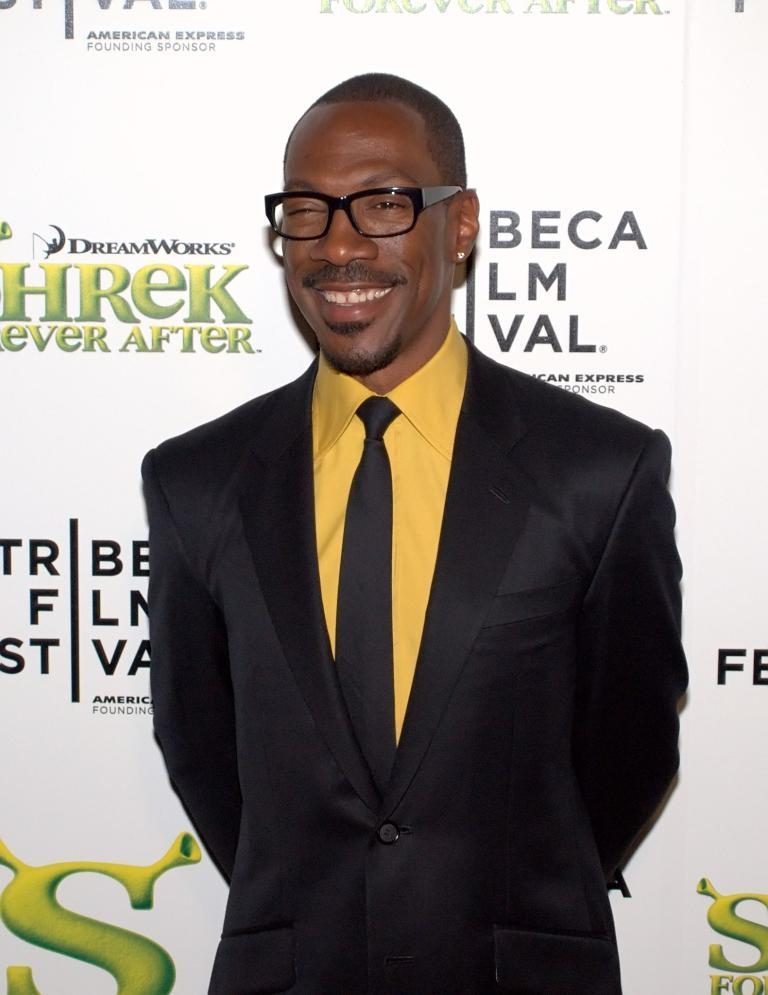What is present in the image? There is a person in the image. Can you describe the person's appearance? The person is wearing spectacles. What else can be seen in the image? There is a banner with some text in the image. What type of action are the birds performing in the image? There are no birds present in the image. Is there a road visible in the image? There is no road visible in the image. 